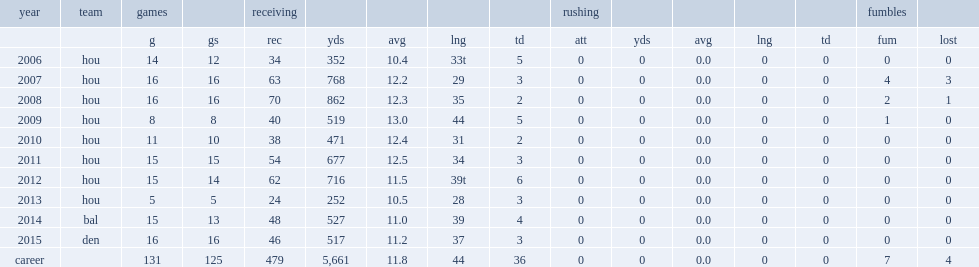In 2006, how many touchdowns did daniels finish his rookie season with? 5.0. 